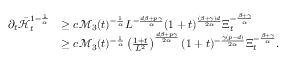Convert formula to latex. <formula><loc_0><loc_0><loc_500><loc_500>\begin{array} { r l } { \partial _ { t } \bar { \mathcal { H } } _ { t } ^ { 1 - \frac { 1 } { \alpha } } } & { \geq c \mathcal { M } _ { 3 } ( t ) ^ { - \frac { 1 } { \alpha } } L ^ { - \frac { d \beta + p \gamma } { \alpha } } ( 1 + t ) ^ { \frac { ( \beta + \gamma ) d } { 2 \alpha } } \Xi _ { t } ^ { - \frac { \beta + \gamma } { \alpha } } } \\ & { \geq c \mathcal { M } _ { 3 } ( t ) ^ { - \frac { 1 } { \alpha } } \left ( \frac { 1 + t } { L ^ { 2 } } \right ) ^ { \frac { d \beta + p \gamma } { 2 \alpha } } ( 1 + t ) ^ { - \frac { \gamma ( p - d ) } { 2 \alpha } } \Xi _ { t } ^ { - \frac { \beta + \gamma } { \alpha } } . } \end{array}</formula> 